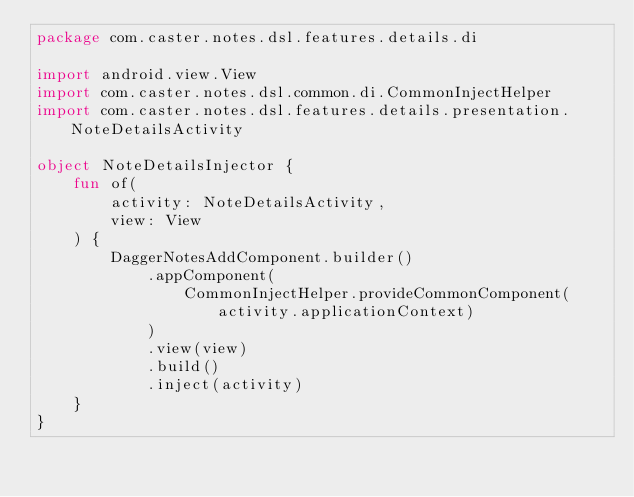<code> <loc_0><loc_0><loc_500><loc_500><_Kotlin_>package com.caster.notes.dsl.features.details.di

import android.view.View
import com.caster.notes.dsl.common.di.CommonInjectHelper
import com.caster.notes.dsl.features.details.presentation.NoteDetailsActivity

object NoteDetailsInjector {
    fun of(
        activity: NoteDetailsActivity,
        view: View
    ) {
        DaggerNotesAddComponent.builder()
            .appComponent(
                CommonInjectHelper.provideCommonComponent(activity.applicationContext)
            )
            .view(view)
            .build()
            .inject(activity)
    }
}</code> 